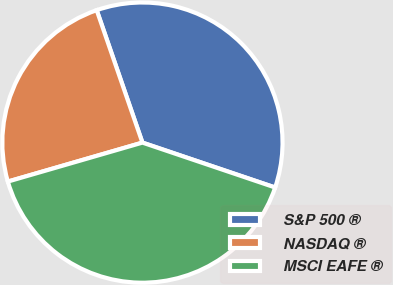Convert chart to OTSL. <chart><loc_0><loc_0><loc_500><loc_500><pie_chart><fcel>S&P 500 ®<fcel>NASDAQ ®<fcel>MSCI EAFE ®<nl><fcel>35.48%<fcel>24.19%<fcel>40.32%<nl></chart> 